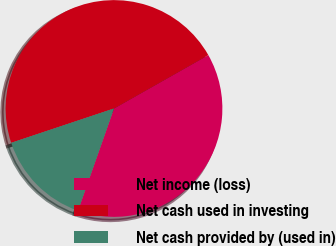<chart> <loc_0><loc_0><loc_500><loc_500><pie_chart><fcel>Net income (loss)<fcel>Net cash used in investing<fcel>Net cash provided by (used in)<nl><fcel>38.59%<fcel>46.93%<fcel>14.48%<nl></chart> 